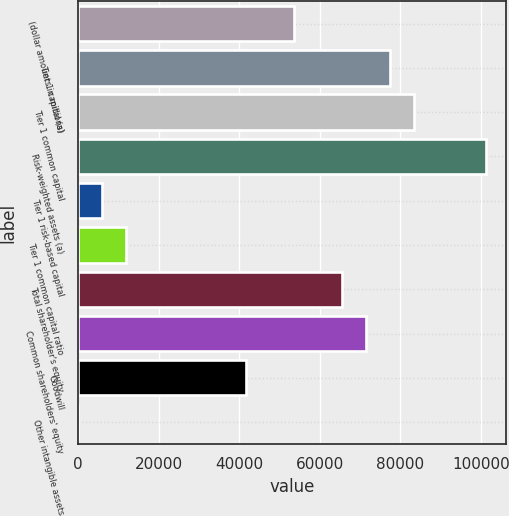<chart> <loc_0><loc_0><loc_500><loc_500><bar_chart><fcel>(dollar amounts in millions)<fcel>Tier 1 capital (a)<fcel>Tier 1 common capital<fcel>Risk-weighted assets (a)<fcel>Tier 1 risk-based capital<fcel>Tier 1 common capital ratio<fcel>Total shareholder's equity<fcel>Common shareholders' equity<fcel>Goodwill<fcel>Other intangible assets<nl><fcel>53556<fcel>77356<fcel>83306<fcel>101156<fcel>5956<fcel>11906<fcel>65456<fcel>71406<fcel>41656<fcel>6<nl></chart> 